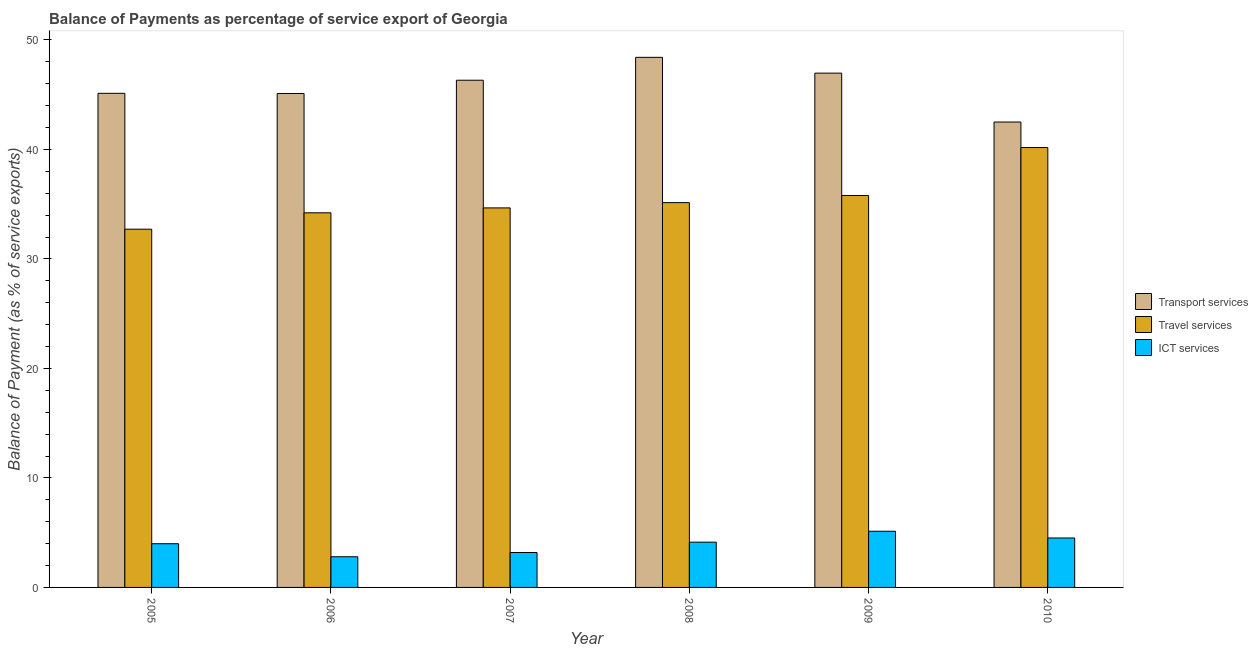How many groups of bars are there?
Your answer should be very brief. 6. Are the number of bars per tick equal to the number of legend labels?
Give a very brief answer. Yes. Are the number of bars on each tick of the X-axis equal?
Provide a short and direct response. Yes. What is the label of the 6th group of bars from the left?
Offer a very short reply. 2010. In how many cases, is the number of bars for a given year not equal to the number of legend labels?
Keep it short and to the point. 0. What is the balance of payment of travel services in 2005?
Your response must be concise. 32.72. Across all years, what is the maximum balance of payment of transport services?
Your answer should be compact. 48.42. Across all years, what is the minimum balance of payment of ict services?
Make the answer very short. 2.8. In which year was the balance of payment of transport services minimum?
Provide a short and direct response. 2010. What is the total balance of payment of travel services in the graph?
Your response must be concise. 212.72. What is the difference between the balance of payment of ict services in 2005 and that in 2007?
Your answer should be compact. 0.8. What is the difference between the balance of payment of ict services in 2010 and the balance of payment of transport services in 2006?
Give a very brief answer. 1.72. What is the average balance of payment of travel services per year?
Offer a very short reply. 35.45. In how many years, is the balance of payment of travel services greater than 32 %?
Your answer should be compact. 6. What is the ratio of the balance of payment of travel services in 2006 to that in 2007?
Provide a short and direct response. 0.99. Is the balance of payment of transport services in 2009 less than that in 2010?
Your response must be concise. No. Is the difference between the balance of payment of ict services in 2008 and 2009 greater than the difference between the balance of payment of transport services in 2008 and 2009?
Make the answer very short. No. What is the difference between the highest and the second highest balance of payment of ict services?
Make the answer very short. 0.61. What is the difference between the highest and the lowest balance of payment of transport services?
Your response must be concise. 5.91. What does the 1st bar from the left in 2005 represents?
Provide a short and direct response. Transport services. What does the 3rd bar from the right in 2006 represents?
Offer a very short reply. Transport services. Is it the case that in every year, the sum of the balance of payment of transport services and balance of payment of travel services is greater than the balance of payment of ict services?
Your response must be concise. Yes. How many bars are there?
Keep it short and to the point. 18. Are all the bars in the graph horizontal?
Ensure brevity in your answer.  No. How many years are there in the graph?
Your response must be concise. 6. What is the difference between two consecutive major ticks on the Y-axis?
Keep it short and to the point. 10. Are the values on the major ticks of Y-axis written in scientific E-notation?
Your answer should be very brief. No. What is the title of the graph?
Offer a very short reply. Balance of Payments as percentage of service export of Georgia. What is the label or title of the Y-axis?
Your response must be concise. Balance of Payment (as % of service exports). What is the Balance of Payment (as % of service exports) in Transport services in 2005?
Provide a short and direct response. 45.13. What is the Balance of Payment (as % of service exports) of Travel services in 2005?
Your answer should be compact. 32.72. What is the Balance of Payment (as % of service exports) of ICT services in 2005?
Offer a very short reply. 3.99. What is the Balance of Payment (as % of service exports) of Transport services in 2006?
Your answer should be compact. 45.11. What is the Balance of Payment (as % of service exports) in Travel services in 2006?
Your answer should be very brief. 34.22. What is the Balance of Payment (as % of service exports) of ICT services in 2006?
Offer a terse response. 2.8. What is the Balance of Payment (as % of service exports) of Transport services in 2007?
Keep it short and to the point. 46.33. What is the Balance of Payment (as % of service exports) of Travel services in 2007?
Your answer should be compact. 34.66. What is the Balance of Payment (as % of service exports) of ICT services in 2007?
Offer a very short reply. 3.19. What is the Balance of Payment (as % of service exports) of Transport services in 2008?
Offer a terse response. 48.42. What is the Balance of Payment (as % of service exports) in Travel services in 2008?
Offer a terse response. 35.15. What is the Balance of Payment (as % of service exports) of ICT services in 2008?
Offer a very short reply. 4.14. What is the Balance of Payment (as % of service exports) of Transport services in 2009?
Your answer should be compact. 46.97. What is the Balance of Payment (as % of service exports) in Travel services in 2009?
Make the answer very short. 35.8. What is the Balance of Payment (as % of service exports) of ICT services in 2009?
Provide a succinct answer. 5.13. What is the Balance of Payment (as % of service exports) of Transport services in 2010?
Make the answer very short. 42.51. What is the Balance of Payment (as % of service exports) of Travel services in 2010?
Keep it short and to the point. 40.18. What is the Balance of Payment (as % of service exports) in ICT services in 2010?
Keep it short and to the point. 4.52. Across all years, what is the maximum Balance of Payment (as % of service exports) in Transport services?
Make the answer very short. 48.42. Across all years, what is the maximum Balance of Payment (as % of service exports) of Travel services?
Your response must be concise. 40.18. Across all years, what is the maximum Balance of Payment (as % of service exports) in ICT services?
Offer a terse response. 5.13. Across all years, what is the minimum Balance of Payment (as % of service exports) of Transport services?
Give a very brief answer. 42.51. Across all years, what is the minimum Balance of Payment (as % of service exports) in Travel services?
Ensure brevity in your answer.  32.72. Across all years, what is the minimum Balance of Payment (as % of service exports) of ICT services?
Offer a very short reply. 2.8. What is the total Balance of Payment (as % of service exports) in Transport services in the graph?
Your answer should be very brief. 274.47. What is the total Balance of Payment (as % of service exports) in Travel services in the graph?
Provide a succinct answer. 212.72. What is the total Balance of Payment (as % of service exports) in ICT services in the graph?
Your answer should be compact. 23.76. What is the difference between the Balance of Payment (as % of service exports) in Transport services in 2005 and that in 2006?
Make the answer very short. 0.02. What is the difference between the Balance of Payment (as % of service exports) of Travel services in 2005 and that in 2006?
Keep it short and to the point. -1.5. What is the difference between the Balance of Payment (as % of service exports) of ICT services in 2005 and that in 2006?
Your answer should be very brief. 1.19. What is the difference between the Balance of Payment (as % of service exports) of Transport services in 2005 and that in 2007?
Offer a very short reply. -1.2. What is the difference between the Balance of Payment (as % of service exports) in Travel services in 2005 and that in 2007?
Give a very brief answer. -1.94. What is the difference between the Balance of Payment (as % of service exports) of ICT services in 2005 and that in 2007?
Ensure brevity in your answer.  0.8. What is the difference between the Balance of Payment (as % of service exports) of Transport services in 2005 and that in 2008?
Make the answer very short. -3.29. What is the difference between the Balance of Payment (as % of service exports) of Travel services in 2005 and that in 2008?
Provide a succinct answer. -2.43. What is the difference between the Balance of Payment (as % of service exports) in ICT services in 2005 and that in 2008?
Make the answer very short. -0.14. What is the difference between the Balance of Payment (as % of service exports) of Transport services in 2005 and that in 2009?
Provide a short and direct response. -1.84. What is the difference between the Balance of Payment (as % of service exports) in Travel services in 2005 and that in 2009?
Offer a terse response. -3.08. What is the difference between the Balance of Payment (as % of service exports) in ICT services in 2005 and that in 2009?
Your answer should be very brief. -1.14. What is the difference between the Balance of Payment (as % of service exports) of Transport services in 2005 and that in 2010?
Offer a very short reply. 2.62. What is the difference between the Balance of Payment (as % of service exports) of Travel services in 2005 and that in 2010?
Keep it short and to the point. -7.46. What is the difference between the Balance of Payment (as % of service exports) in ICT services in 2005 and that in 2010?
Your answer should be very brief. -0.53. What is the difference between the Balance of Payment (as % of service exports) in Transport services in 2006 and that in 2007?
Your answer should be compact. -1.21. What is the difference between the Balance of Payment (as % of service exports) of Travel services in 2006 and that in 2007?
Keep it short and to the point. -0.45. What is the difference between the Balance of Payment (as % of service exports) in ICT services in 2006 and that in 2007?
Provide a succinct answer. -0.39. What is the difference between the Balance of Payment (as % of service exports) in Transport services in 2006 and that in 2008?
Offer a very short reply. -3.3. What is the difference between the Balance of Payment (as % of service exports) in Travel services in 2006 and that in 2008?
Make the answer very short. -0.93. What is the difference between the Balance of Payment (as % of service exports) of ICT services in 2006 and that in 2008?
Offer a very short reply. -1.33. What is the difference between the Balance of Payment (as % of service exports) of Transport services in 2006 and that in 2009?
Your answer should be very brief. -1.86. What is the difference between the Balance of Payment (as % of service exports) of Travel services in 2006 and that in 2009?
Provide a succinct answer. -1.58. What is the difference between the Balance of Payment (as % of service exports) in ICT services in 2006 and that in 2009?
Give a very brief answer. -2.33. What is the difference between the Balance of Payment (as % of service exports) of Transport services in 2006 and that in 2010?
Your response must be concise. 2.61. What is the difference between the Balance of Payment (as % of service exports) in Travel services in 2006 and that in 2010?
Ensure brevity in your answer.  -5.96. What is the difference between the Balance of Payment (as % of service exports) of ICT services in 2006 and that in 2010?
Your response must be concise. -1.72. What is the difference between the Balance of Payment (as % of service exports) in Transport services in 2007 and that in 2008?
Your answer should be very brief. -2.09. What is the difference between the Balance of Payment (as % of service exports) of Travel services in 2007 and that in 2008?
Ensure brevity in your answer.  -0.48. What is the difference between the Balance of Payment (as % of service exports) of ICT services in 2007 and that in 2008?
Ensure brevity in your answer.  -0.95. What is the difference between the Balance of Payment (as % of service exports) in Transport services in 2007 and that in 2009?
Make the answer very short. -0.65. What is the difference between the Balance of Payment (as % of service exports) of Travel services in 2007 and that in 2009?
Provide a short and direct response. -1.14. What is the difference between the Balance of Payment (as % of service exports) of ICT services in 2007 and that in 2009?
Make the answer very short. -1.94. What is the difference between the Balance of Payment (as % of service exports) of Transport services in 2007 and that in 2010?
Your response must be concise. 3.82. What is the difference between the Balance of Payment (as % of service exports) of Travel services in 2007 and that in 2010?
Give a very brief answer. -5.51. What is the difference between the Balance of Payment (as % of service exports) of ICT services in 2007 and that in 2010?
Give a very brief answer. -1.33. What is the difference between the Balance of Payment (as % of service exports) in Transport services in 2008 and that in 2009?
Provide a short and direct response. 1.44. What is the difference between the Balance of Payment (as % of service exports) of Travel services in 2008 and that in 2009?
Keep it short and to the point. -0.65. What is the difference between the Balance of Payment (as % of service exports) in ICT services in 2008 and that in 2009?
Your answer should be compact. -1. What is the difference between the Balance of Payment (as % of service exports) in Transport services in 2008 and that in 2010?
Offer a very short reply. 5.91. What is the difference between the Balance of Payment (as % of service exports) in Travel services in 2008 and that in 2010?
Offer a very short reply. -5.03. What is the difference between the Balance of Payment (as % of service exports) in ICT services in 2008 and that in 2010?
Your response must be concise. -0.38. What is the difference between the Balance of Payment (as % of service exports) of Transport services in 2009 and that in 2010?
Keep it short and to the point. 4.47. What is the difference between the Balance of Payment (as % of service exports) in Travel services in 2009 and that in 2010?
Keep it short and to the point. -4.38. What is the difference between the Balance of Payment (as % of service exports) in ICT services in 2009 and that in 2010?
Keep it short and to the point. 0.61. What is the difference between the Balance of Payment (as % of service exports) of Transport services in 2005 and the Balance of Payment (as % of service exports) of Travel services in 2006?
Make the answer very short. 10.91. What is the difference between the Balance of Payment (as % of service exports) in Transport services in 2005 and the Balance of Payment (as % of service exports) in ICT services in 2006?
Your response must be concise. 42.33. What is the difference between the Balance of Payment (as % of service exports) of Travel services in 2005 and the Balance of Payment (as % of service exports) of ICT services in 2006?
Ensure brevity in your answer.  29.92. What is the difference between the Balance of Payment (as % of service exports) of Transport services in 2005 and the Balance of Payment (as % of service exports) of Travel services in 2007?
Ensure brevity in your answer.  10.47. What is the difference between the Balance of Payment (as % of service exports) in Transport services in 2005 and the Balance of Payment (as % of service exports) in ICT services in 2007?
Your response must be concise. 41.94. What is the difference between the Balance of Payment (as % of service exports) of Travel services in 2005 and the Balance of Payment (as % of service exports) of ICT services in 2007?
Provide a succinct answer. 29.53. What is the difference between the Balance of Payment (as % of service exports) of Transport services in 2005 and the Balance of Payment (as % of service exports) of Travel services in 2008?
Provide a short and direct response. 9.99. What is the difference between the Balance of Payment (as % of service exports) in Transport services in 2005 and the Balance of Payment (as % of service exports) in ICT services in 2008?
Offer a very short reply. 40.99. What is the difference between the Balance of Payment (as % of service exports) of Travel services in 2005 and the Balance of Payment (as % of service exports) of ICT services in 2008?
Your response must be concise. 28.58. What is the difference between the Balance of Payment (as % of service exports) in Transport services in 2005 and the Balance of Payment (as % of service exports) in Travel services in 2009?
Offer a terse response. 9.33. What is the difference between the Balance of Payment (as % of service exports) in Transport services in 2005 and the Balance of Payment (as % of service exports) in ICT services in 2009?
Provide a short and direct response. 40. What is the difference between the Balance of Payment (as % of service exports) in Travel services in 2005 and the Balance of Payment (as % of service exports) in ICT services in 2009?
Give a very brief answer. 27.59. What is the difference between the Balance of Payment (as % of service exports) of Transport services in 2005 and the Balance of Payment (as % of service exports) of Travel services in 2010?
Make the answer very short. 4.95. What is the difference between the Balance of Payment (as % of service exports) of Transport services in 2005 and the Balance of Payment (as % of service exports) of ICT services in 2010?
Make the answer very short. 40.61. What is the difference between the Balance of Payment (as % of service exports) in Travel services in 2005 and the Balance of Payment (as % of service exports) in ICT services in 2010?
Provide a short and direct response. 28.2. What is the difference between the Balance of Payment (as % of service exports) in Transport services in 2006 and the Balance of Payment (as % of service exports) in Travel services in 2007?
Your answer should be very brief. 10.45. What is the difference between the Balance of Payment (as % of service exports) of Transport services in 2006 and the Balance of Payment (as % of service exports) of ICT services in 2007?
Ensure brevity in your answer.  41.93. What is the difference between the Balance of Payment (as % of service exports) in Travel services in 2006 and the Balance of Payment (as % of service exports) in ICT services in 2007?
Provide a succinct answer. 31.03. What is the difference between the Balance of Payment (as % of service exports) of Transport services in 2006 and the Balance of Payment (as % of service exports) of Travel services in 2008?
Ensure brevity in your answer.  9.97. What is the difference between the Balance of Payment (as % of service exports) in Transport services in 2006 and the Balance of Payment (as % of service exports) in ICT services in 2008?
Provide a succinct answer. 40.98. What is the difference between the Balance of Payment (as % of service exports) of Travel services in 2006 and the Balance of Payment (as % of service exports) of ICT services in 2008?
Offer a very short reply. 30.08. What is the difference between the Balance of Payment (as % of service exports) in Transport services in 2006 and the Balance of Payment (as % of service exports) in Travel services in 2009?
Your answer should be very brief. 9.31. What is the difference between the Balance of Payment (as % of service exports) in Transport services in 2006 and the Balance of Payment (as % of service exports) in ICT services in 2009?
Ensure brevity in your answer.  39.98. What is the difference between the Balance of Payment (as % of service exports) in Travel services in 2006 and the Balance of Payment (as % of service exports) in ICT services in 2009?
Offer a terse response. 29.09. What is the difference between the Balance of Payment (as % of service exports) in Transport services in 2006 and the Balance of Payment (as % of service exports) in Travel services in 2010?
Make the answer very short. 4.94. What is the difference between the Balance of Payment (as % of service exports) of Transport services in 2006 and the Balance of Payment (as % of service exports) of ICT services in 2010?
Ensure brevity in your answer.  40.6. What is the difference between the Balance of Payment (as % of service exports) in Travel services in 2006 and the Balance of Payment (as % of service exports) in ICT services in 2010?
Offer a terse response. 29.7. What is the difference between the Balance of Payment (as % of service exports) in Transport services in 2007 and the Balance of Payment (as % of service exports) in Travel services in 2008?
Provide a succinct answer. 11.18. What is the difference between the Balance of Payment (as % of service exports) of Transport services in 2007 and the Balance of Payment (as % of service exports) of ICT services in 2008?
Ensure brevity in your answer.  42.19. What is the difference between the Balance of Payment (as % of service exports) in Travel services in 2007 and the Balance of Payment (as % of service exports) in ICT services in 2008?
Offer a very short reply. 30.53. What is the difference between the Balance of Payment (as % of service exports) of Transport services in 2007 and the Balance of Payment (as % of service exports) of Travel services in 2009?
Keep it short and to the point. 10.53. What is the difference between the Balance of Payment (as % of service exports) in Transport services in 2007 and the Balance of Payment (as % of service exports) in ICT services in 2009?
Your answer should be very brief. 41.19. What is the difference between the Balance of Payment (as % of service exports) in Travel services in 2007 and the Balance of Payment (as % of service exports) in ICT services in 2009?
Keep it short and to the point. 29.53. What is the difference between the Balance of Payment (as % of service exports) in Transport services in 2007 and the Balance of Payment (as % of service exports) in Travel services in 2010?
Provide a short and direct response. 6.15. What is the difference between the Balance of Payment (as % of service exports) of Transport services in 2007 and the Balance of Payment (as % of service exports) of ICT services in 2010?
Offer a very short reply. 41.81. What is the difference between the Balance of Payment (as % of service exports) in Travel services in 2007 and the Balance of Payment (as % of service exports) in ICT services in 2010?
Provide a succinct answer. 30.15. What is the difference between the Balance of Payment (as % of service exports) in Transport services in 2008 and the Balance of Payment (as % of service exports) in Travel services in 2009?
Ensure brevity in your answer.  12.62. What is the difference between the Balance of Payment (as % of service exports) in Transport services in 2008 and the Balance of Payment (as % of service exports) in ICT services in 2009?
Offer a terse response. 43.29. What is the difference between the Balance of Payment (as % of service exports) of Travel services in 2008 and the Balance of Payment (as % of service exports) of ICT services in 2009?
Keep it short and to the point. 30.01. What is the difference between the Balance of Payment (as % of service exports) of Transport services in 2008 and the Balance of Payment (as % of service exports) of Travel services in 2010?
Your answer should be compact. 8.24. What is the difference between the Balance of Payment (as % of service exports) of Transport services in 2008 and the Balance of Payment (as % of service exports) of ICT services in 2010?
Give a very brief answer. 43.9. What is the difference between the Balance of Payment (as % of service exports) of Travel services in 2008 and the Balance of Payment (as % of service exports) of ICT services in 2010?
Provide a short and direct response. 30.63. What is the difference between the Balance of Payment (as % of service exports) of Transport services in 2009 and the Balance of Payment (as % of service exports) of Travel services in 2010?
Your answer should be very brief. 6.8. What is the difference between the Balance of Payment (as % of service exports) of Transport services in 2009 and the Balance of Payment (as % of service exports) of ICT services in 2010?
Keep it short and to the point. 42.46. What is the difference between the Balance of Payment (as % of service exports) in Travel services in 2009 and the Balance of Payment (as % of service exports) in ICT services in 2010?
Offer a terse response. 31.28. What is the average Balance of Payment (as % of service exports) of Transport services per year?
Keep it short and to the point. 45.74. What is the average Balance of Payment (as % of service exports) in Travel services per year?
Keep it short and to the point. 35.45. What is the average Balance of Payment (as % of service exports) in ICT services per year?
Keep it short and to the point. 3.96. In the year 2005, what is the difference between the Balance of Payment (as % of service exports) in Transport services and Balance of Payment (as % of service exports) in Travel services?
Give a very brief answer. 12.41. In the year 2005, what is the difference between the Balance of Payment (as % of service exports) in Transport services and Balance of Payment (as % of service exports) in ICT services?
Provide a short and direct response. 41.14. In the year 2005, what is the difference between the Balance of Payment (as % of service exports) of Travel services and Balance of Payment (as % of service exports) of ICT services?
Ensure brevity in your answer.  28.73. In the year 2006, what is the difference between the Balance of Payment (as % of service exports) of Transport services and Balance of Payment (as % of service exports) of Travel services?
Your answer should be very brief. 10.9. In the year 2006, what is the difference between the Balance of Payment (as % of service exports) of Transport services and Balance of Payment (as % of service exports) of ICT services?
Offer a terse response. 42.31. In the year 2006, what is the difference between the Balance of Payment (as % of service exports) of Travel services and Balance of Payment (as % of service exports) of ICT services?
Keep it short and to the point. 31.42. In the year 2007, what is the difference between the Balance of Payment (as % of service exports) in Transport services and Balance of Payment (as % of service exports) in Travel services?
Offer a very short reply. 11.66. In the year 2007, what is the difference between the Balance of Payment (as % of service exports) in Transport services and Balance of Payment (as % of service exports) in ICT services?
Keep it short and to the point. 43.14. In the year 2007, what is the difference between the Balance of Payment (as % of service exports) in Travel services and Balance of Payment (as % of service exports) in ICT services?
Make the answer very short. 31.48. In the year 2008, what is the difference between the Balance of Payment (as % of service exports) in Transport services and Balance of Payment (as % of service exports) in Travel services?
Provide a succinct answer. 13.27. In the year 2008, what is the difference between the Balance of Payment (as % of service exports) of Transport services and Balance of Payment (as % of service exports) of ICT services?
Your answer should be compact. 44.28. In the year 2008, what is the difference between the Balance of Payment (as % of service exports) of Travel services and Balance of Payment (as % of service exports) of ICT services?
Your answer should be very brief. 31.01. In the year 2009, what is the difference between the Balance of Payment (as % of service exports) of Transport services and Balance of Payment (as % of service exports) of Travel services?
Give a very brief answer. 11.17. In the year 2009, what is the difference between the Balance of Payment (as % of service exports) of Transport services and Balance of Payment (as % of service exports) of ICT services?
Keep it short and to the point. 41.84. In the year 2009, what is the difference between the Balance of Payment (as % of service exports) in Travel services and Balance of Payment (as % of service exports) in ICT services?
Your response must be concise. 30.67. In the year 2010, what is the difference between the Balance of Payment (as % of service exports) in Transport services and Balance of Payment (as % of service exports) in Travel services?
Offer a terse response. 2.33. In the year 2010, what is the difference between the Balance of Payment (as % of service exports) of Transport services and Balance of Payment (as % of service exports) of ICT services?
Provide a succinct answer. 37.99. In the year 2010, what is the difference between the Balance of Payment (as % of service exports) in Travel services and Balance of Payment (as % of service exports) in ICT services?
Offer a terse response. 35.66. What is the ratio of the Balance of Payment (as % of service exports) of Transport services in 2005 to that in 2006?
Make the answer very short. 1. What is the ratio of the Balance of Payment (as % of service exports) of Travel services in 2005 to that in 2006?
Provide a succinct answer. 0.96. What is the ratio of the Balance of Payment (as % of service exports) in ICT services in 2005 to that in 2006?
Your answer should be compact. 1.42. What is the ratio of the Balance of Payment (as % of service exports) in Transport services in 2005 to that in 2007?
Offer a very short reply. 0.97. What is the ratio of the Balance of Payment (as % of service exports) of Travel services in 2005 to that in 2007?
Ensure brevity in your answer.  0.94. What is the ratio of the Balance of Payment (as % of service exports) in ICT services in 2005 to that in 2007?
Ensure brevity in your answer.  1.25. What is the ratio of the Balance of Payment (as % of service exports) of Transport services in 2005 to that in 2008?
Ensure brevity in your answer.  0.93. What is the ratio of the Balance of Payment (as % of service exports) of ICT services in 2005 to that in 2008?
Provide a succinct answer. 0.97. What is the ratio of the Balance of Payment (as % of service exports) in Transport services in 2005 to that in 2009?
Ensure brevity in your answer.  0.96. What is the ratio of the Balance of Payment (as % of service exports) of Travel services in 2005 to that in 2009?
Provide a short and direct response. 0.91. What is the ratio of the Balance of Payment (as % of service exports) in Transport services in 2005 to that in 2010?
Your answer should be very brief. 1.06. What is the ratio of the Balance of Payment (as % of service exports) in Travel services in 2005 to that in 2010?
Your answer should be compact. 0.81. What is the ratio of the Balance of Payment (as % of service exports) of ICT services in 2005 to that in 2010?
Your answer should be very brief. 0.88. What is the ratio of the Balance of Payment (as % of service exports) in Transport services in 2006 to that in 2007?
Offer a terse response. 0.97. What is the ratio of the Balance of Payment (as % of service exports) of Travel services in 2006 to that in 2007?
Provide a short and direct response. 0.99. What is the ratio of the Balance of Payment (as % of service exports) of ICT services in 2006 to that in 2007?
Make the answer very short. 0.88. What is the ratio of the Balance of Payment (as % of service exports) of Transport services in 2006 to that in 2008?
Keep it short and to the point. 0.93. What is the ratio of the Balance of Payment (as % of service exports) of Travel services in 2006 to that in 2008?
Ensure brevity in your answer.  0.97. What is the ratio of the Balance of Payment (as % of service exports) of ICT services in 2006 to that in 2008?
Your response must be concise. 0.68. What is the ratio of the Balance of Payment (as % of service exports) of Transport services in 2006 to that in 2009?
Make the answer very short. 0.96. What is the ratio of the Balance of Payment (as % of service exports) of Travel services in 2006 to that in 2009?
Provide a succinct answer. 0.96. What is the ratio of the Balance of Payment (as % of service exports) of ICT services in 2006 to that in 2009?
Make the answer very short. 0.55. What is the ratio of the Balance of Payment (as % of service exports) of Transport services in 2006 to that in 2010?
Keep it short and to the point. 1.06. What is the ratio of the Balance of Payment (as % of service exports) in Travel services in 2006 to that in 2010?
Ensure brevity in your answer.  0.85. What is the ratio of the Balance of Payment (as % of service exports) in ICT services in 2006 to that in 2010?
Provide a short and direct response. 0.62. What is the ratio of the Balance of Payment (as % of service exports) in Transport services in 2007 to that in 2008?
Offer a very short reply. 0.96. What is the ratio of the Balance of Payment (as % of service exports) in Travel services in 2007 to that in 2008?
Your response must be concise. 0.99. What is the ratio of the Balance of Payment (as % of service exports) in ICT services in 2007 to that in 2008?
Keep it short and to the point. 0.77. What is the ratio of the Balance of Payment (as % of service exports) in Transport services in 2007 to that in 2009?
Your response must be concise. 0.99. What is the ratio of the Balance of Payment (as % of service exports) in Travel services in 2007 to that in 2009?
Keep it short and to the point. 0.97. What is the ratio of the Balance of Payment (as % of service exports) of ICT services in 2007 to that in 2009?
Keep it short and to the point. 0.62. What is the ratio of the Balance of Payment (as % of service exports) in Transport services in 2007 to that in 2010?
Keep it short and to the point. 1.09. What is the ratio of the Balance of Payment (as % of service exports) in Travel services in 2007 to that in 2010?
Provide a short and direct response. 0.86. What is the ratio of the Balance of Payment (as % of service exports) in ICT services in 2007 to that in 2010?
Provide a short and direct response. 0.71. What is the ratio of the Balance of Payment (as % of service exports) of Transport services in 2008 to that in 2009?
Ensure brevity in your answer.  1.03. What is the ratio of the Balance of Payment (as % of service exports) of Travel services in 2008 to that in 2009?
Provide a short and direct response. 0.98. What is the ratio of the Balance of Payment (as % of service exports) in ICT services in 2008 to that in 2009?
Keep it short and to the point. 0.81. What is the ratio of the Balance of Payment (as % of service exports) in Transport services in 2008 to that in 2010?
Ensure brevity in your answer.  1.14. What is the ratio of the Balance of Payment (as % of service exports) of Travel services in 2008 to that in 2010?
Provide a short and direct response. 0.87. What is the ratio of the Balance of Payment (as % of service exports) in ICT services in 2008 to that in 2010?
Your answer should be very brief. 0.92. What is the ratio of the Balance of Payment (as % of service exports) of Transport services in 2009 to that in 2010?
Provide a succinct answer. 1.1. What is the ratio of the Balance of Payment (as % of service exports) in Travel services in 2009 to that in 2010?
Keep it short and to the point. 0.89. What is the ratio of the Balance of Payment (as % of service exports) in ICT services in 2009 to that in 2010?
Your response must be concise. 1.14. What is the difference between the highest and the second highest Balance of Payment (as % of service exports) of Transport services?
Make the answer very short. 1.44. What is the difference between the highest and the second highest Balance of Payment (as % of service exports) of Travel services?
Provide a succinct answer. 4.38. What is the difference between the highest and the second highest Balance of Payment (as % of service exports) in ICT services?
Provide a succinct answer. 0.61. What is the difference between the highest and the lowest Balance of Payment (as % of service exports) of Transport services?
Offer a terse response. 5.91. What is the difference between the highest and the lowest Balance of Payment (as % of service exports) in Travel services?
Your response must be concise. 7.46. What is the difference between the highest and the lowest Balance of Payment (as % of service exports) of ICT services?
Ensure brevity in your answer.  2.33. 